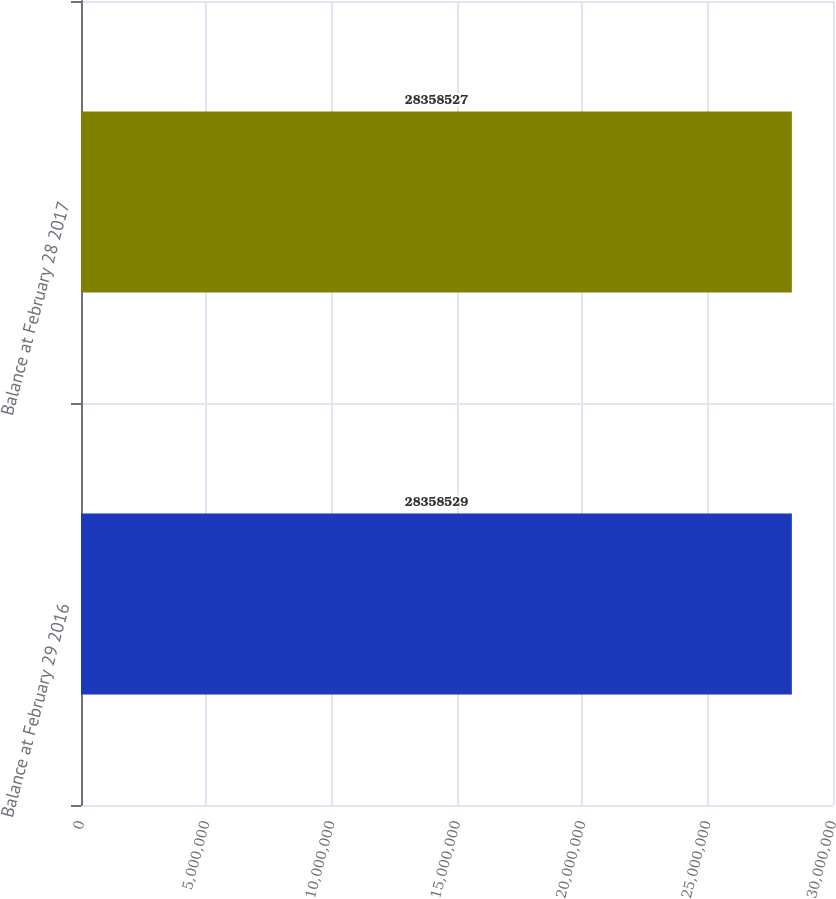Convert chart. <chart><loc_0><loc_0><loc_500><loc_500><bar_chart><fcel>Balance at February 29 2016<fcel>Balance at February 28 2017<nl><fcel>2.83585e+07<fcel>2.83585e+07<nl></chart> 